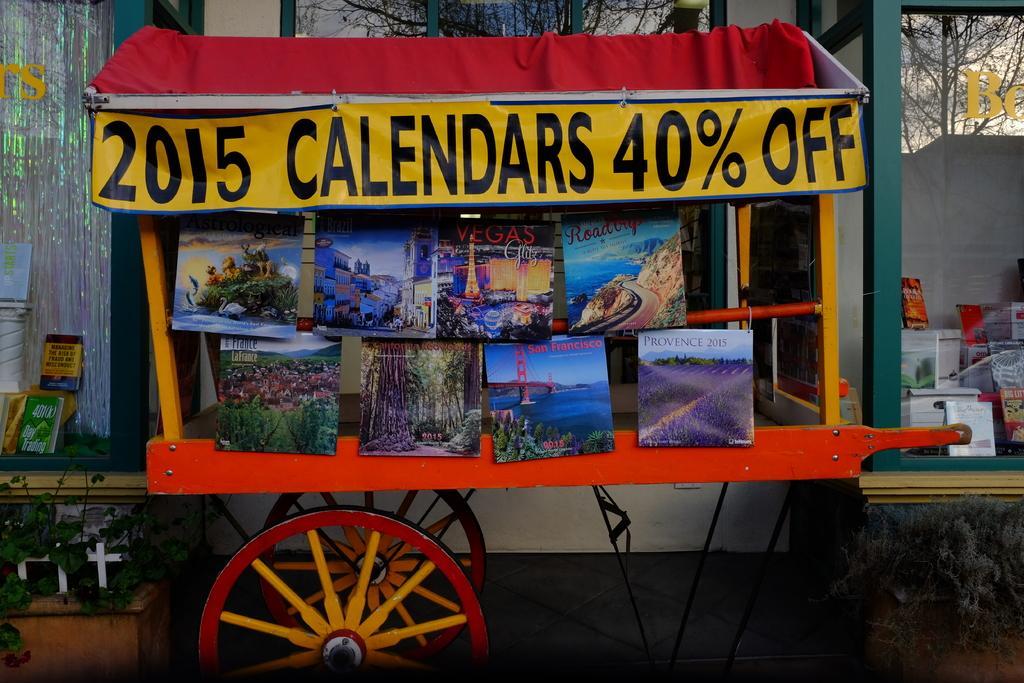In one or two sentences, can you explain what this image depicts? In this image I can see an orange colour chart. I can also see a yellow colour banner and on it I can see something is written. Here I can see few sceneries. In the background I can see few books and I can see few other stuffs. 